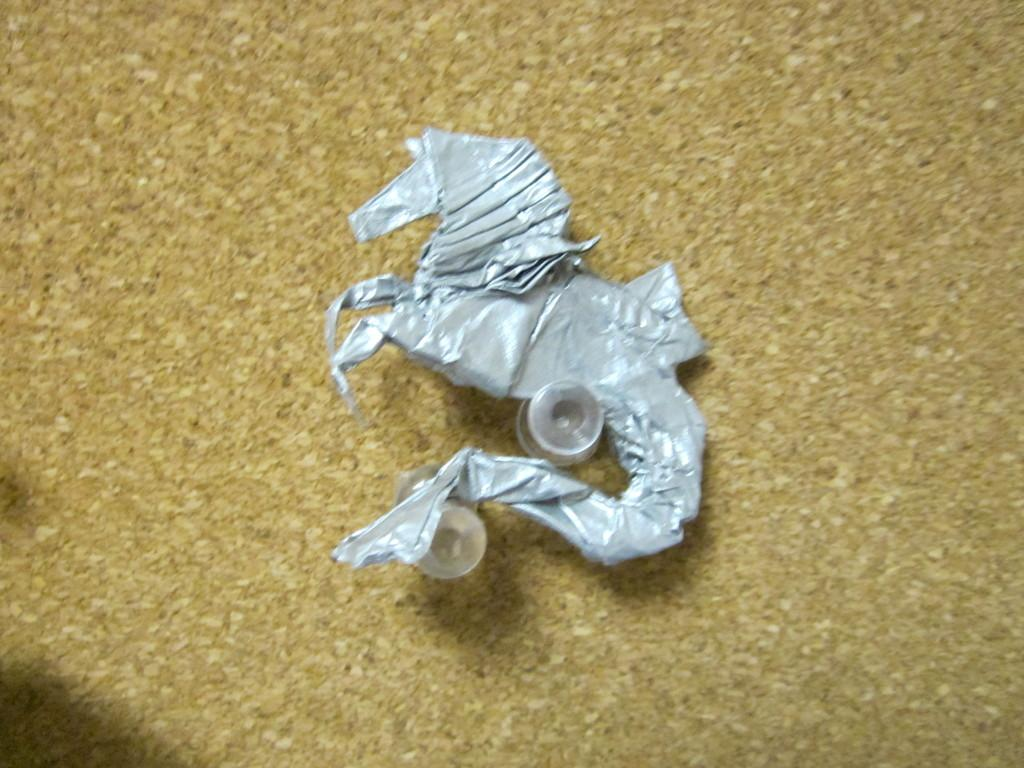What type of craft is featured in the image? There is paper craft in the image. What can be seen on the surface in the image? There are white objects on the surface in the image. How many letters are present in the paper craft in the image? There is no indication of letters in the paper craft in the image. 